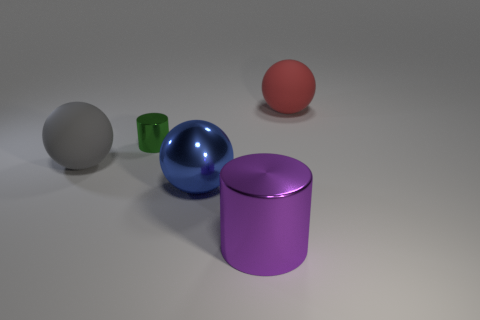Is there anything else that is the same size as the green cylinder?
Provide a short and direct response. No. What number of large things are red metallic balls or green metallic cylinders?
Offer a very short reply. 0. What color is the big thing that is on the right side of the large blue object and behind the purple metal object?
Provide a short and direct response. Red. Is there a green metallic thing that has the same shape as the purple shiny object?
Provide a succinct answer. Yes. What is the material of the big purple object?
Give a very brief answer. Metal. Are there any red things behind the metal ball?
Make the answer very short. Yes. Is the purple object the same shape as the gray thing?
Give a very brief answer. No. How many other objects are the same size as the green metal cylinder?
Ensure brevity in your answer.  0. How many things are purple cylinders that are in front of the large gray rubber thing or purple cylinders?
Ensure brevity in your answer.  1. The small cylinder is what color?
Give a very brief answer. Green. 